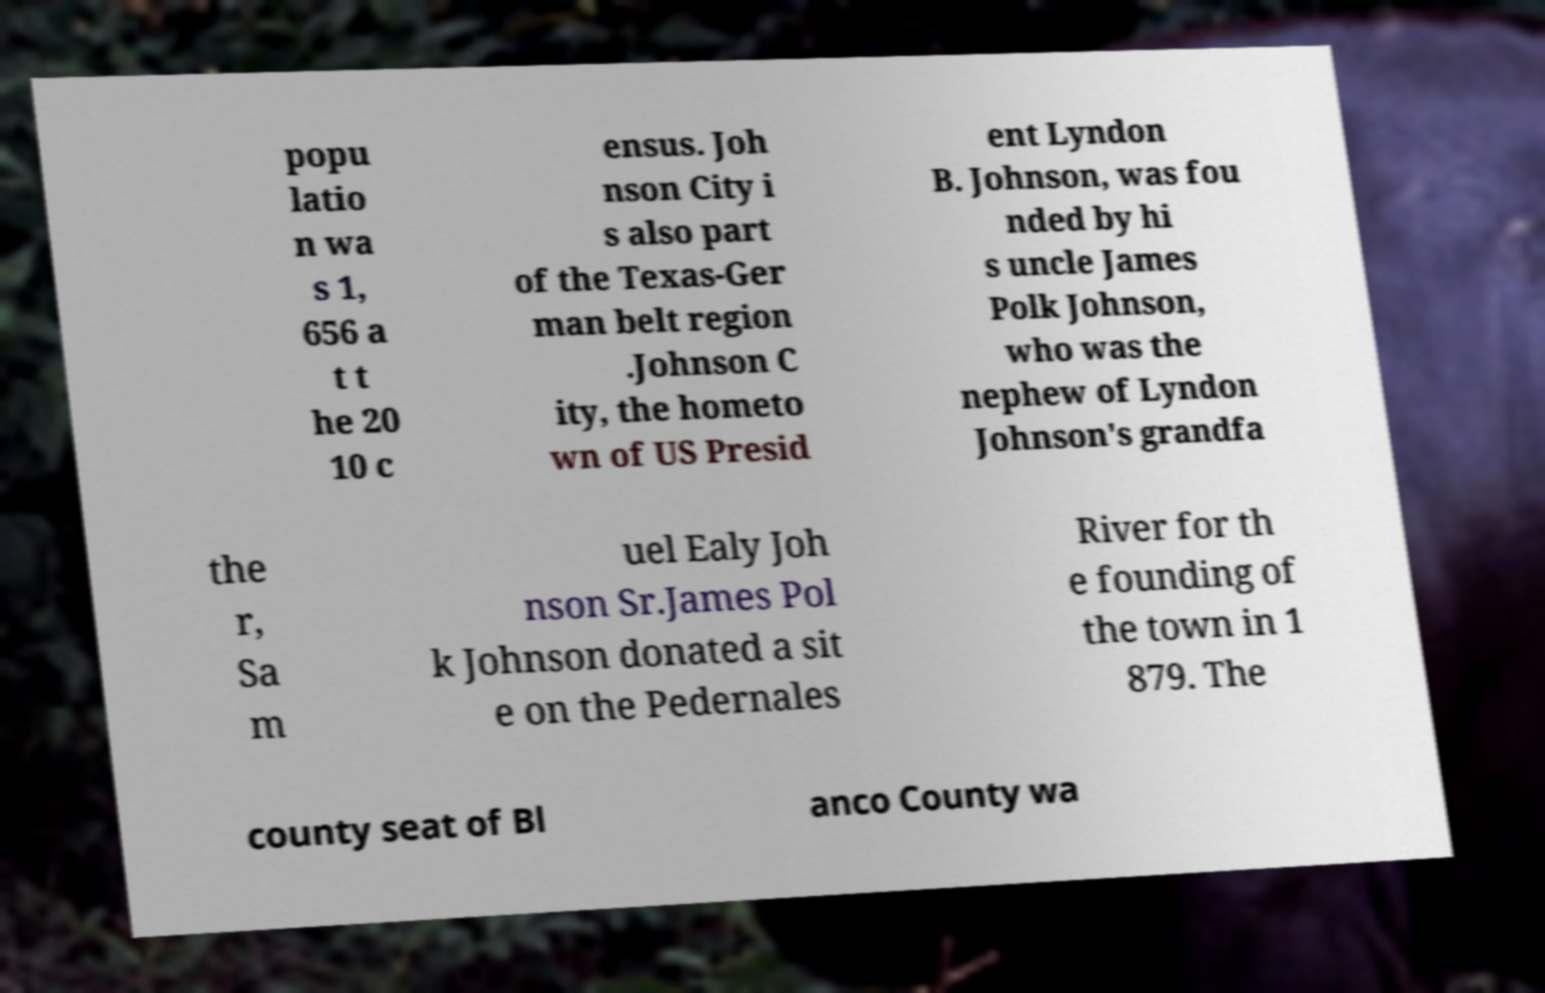Could you assist in decoding the text presented in this image and type it out clearly? popu latio n wa s 1, 656 a t t he 20 10 c ensus. Joh nson City i s also part of the Texas-Ger man belt region .Johnson C ity, the hometo wn of US Presid ent Lyndon B. Johnson, was fou nded by hi s uncle James Polk Johnson, who was the nephew of Lyndon Johnson's grandfa the r, Sa m uel Ealy Joh nson Sr.James Pol k Johnson donated a sit e on the Pedernales River for th e founding of the town in 1 879. The county seat of Bl anco County wa 